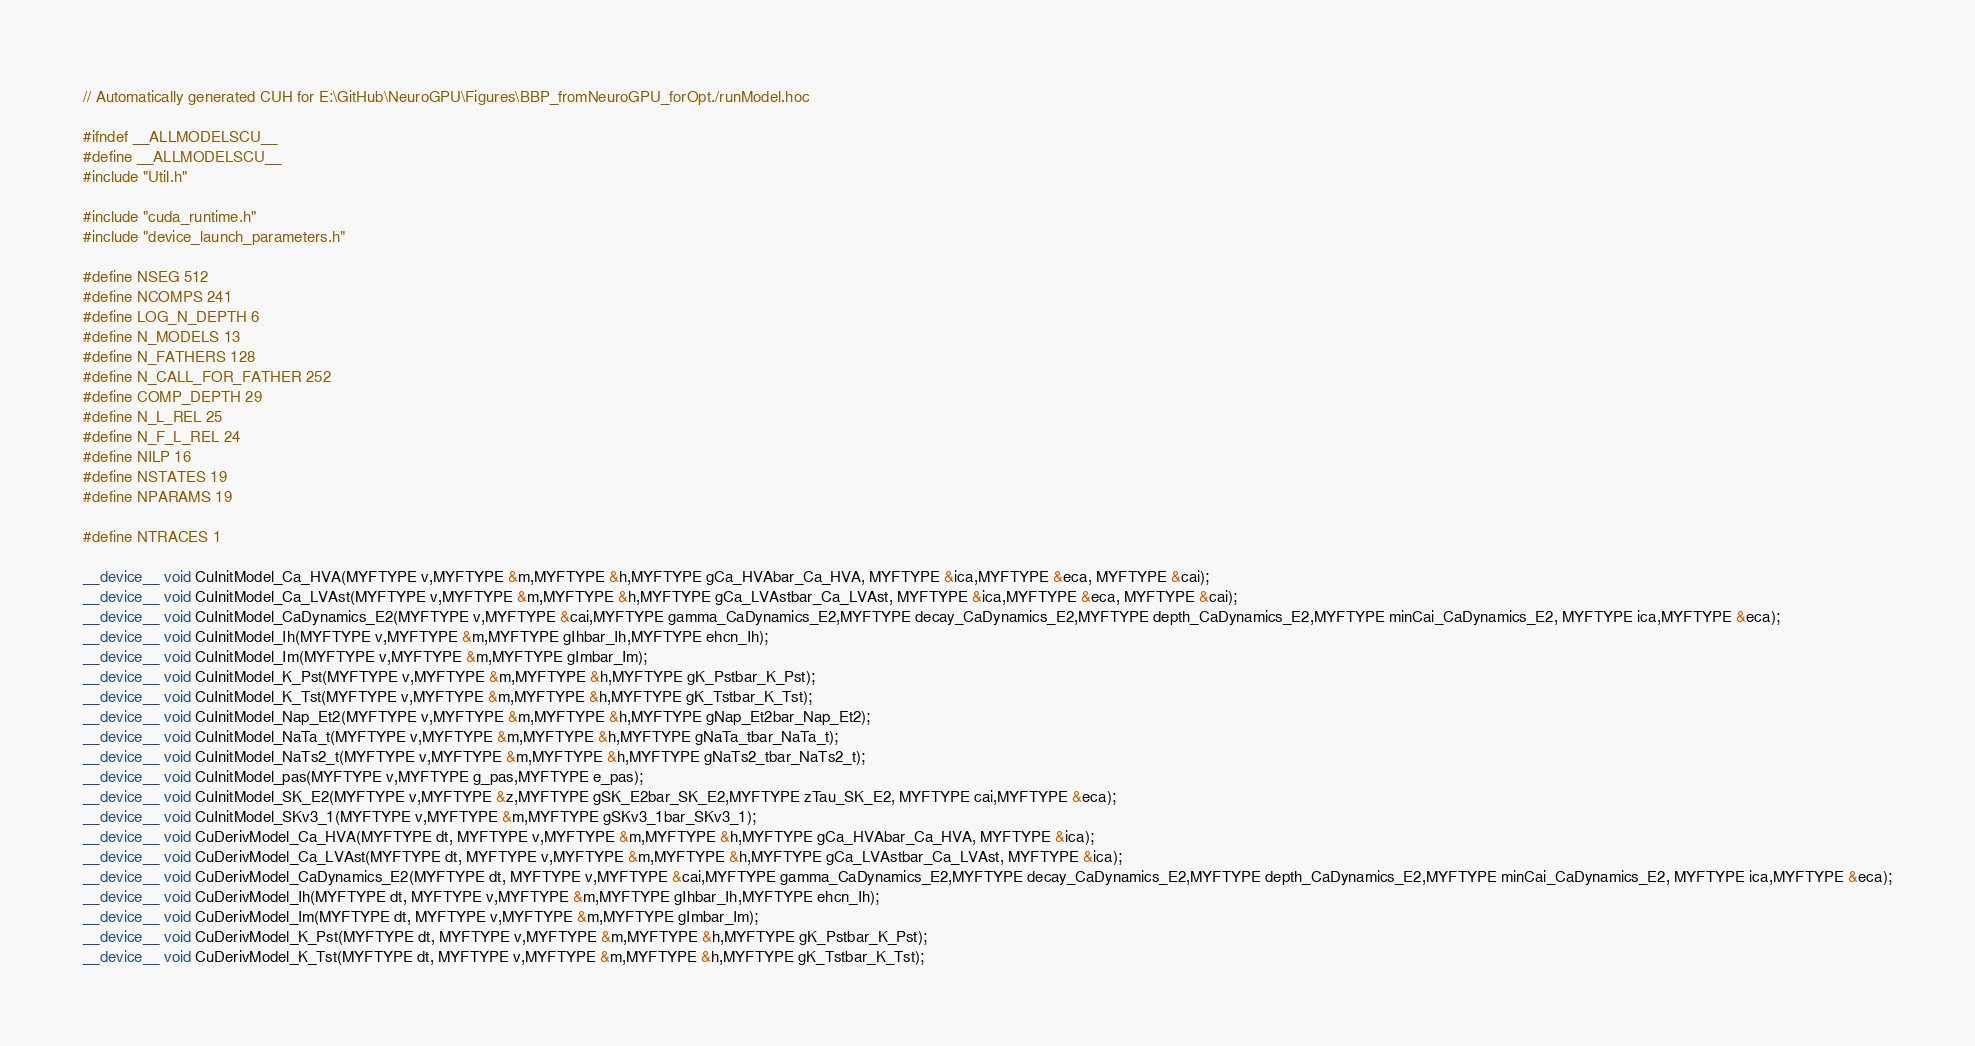<code> <loc_0><loc_0><loc_500><loc_500><_Cuda_>// Automatically generated CUH for E:\GitHub\NeuroGPU\Figures\BBP_fromNeuroGPU_forOpt./runModel.hoc

#ifndef __ALLMODELSCU__
#define __ALLMODELSCU__
#include "Util.h"

#include "cuda_runtime.h"
#include "device_launch_parameters.h"

#define NSEG 512
#define NCOMPS 241
#define LOG_N_DEPTH 6
#define N_MODELS 13
#define N_FATHERS 128
#define N_CALL_FOR_FATHER 252
#define COMP_DEPTH 29
#define N_L_REL 25
#define N_F_L_REL 24
#define NILP 16
#define NSTATES 19
#define NPARAMS 19

#define NTRACES 1

__device__ void CuInitModel_Ca_HVA(MYFTYPE v,MYFTYPE &m,MYFTYPE &h,MYFTYPE gCa_HVAbar_Ca_HVA, MYFTYPE &ica,MYFTYPE &eca, MYFTYPE &cai);
__device__ void CuInitModel_Ca_LVAst(MYFTYPE v,MYFTYPE &m,MYFTYPE &h,MYFTYPE gCa_LVAstbar_Ca_LVAst, MYFTYPE &ica,MYFTYPE &eca, MYFTYPE &cai);
__device__ void CuInitModel_CaDynamics_E2(MYFTYPE v,MYFTYPE &cai,MYFTYPE gamma_CaDynamics_E2,MYFTYPE decay_CaDynamics_E2,MYFTYPE depth_CaDynamics_E2,MYFTYPE minCai_CaDynamics_E2, MYFTYPE ica,MYFTYPE &eca);
__device__ void CuInitModel_Ih(MYFTYPE v,MYFTYPE &m,MYFTYPE gIhbar_Ih,MYFTYPE ehcn_Ih);
__device__ void CuInitModel_Im(MYFTYPE v,MYFTYPE &m,MYFTYPE gImbar_Im);
__device__ void CuInitModel_K_Pst(MYFTYPE v,MYFTYPE &m,MYFTYPE &h,MYFTYPE gK_Pstbar_K_Pst);
__device__ void CuInitModel_K_Tst(MYFTYPE v,MYFTYPE &m,MYFTYPE &h,MYFTYPE gK_Tstbar_K_Tst);
__device__ void CuInitModel_Nap_Et2(MYFTYPE v,MYFTYPE &m,MYFTYPE &h,MYFTYPE gNap_Et2bar_Nap_Et2);
__device__ void CuInitModel_NaTa_t(MYFTYPE v,MYFTYPE &m,MYFTYPE &h,MYFTYPE gNaTa_tbar_NaTa_t);
__device__ void CuInitModel_NaTs2_t(MYFTYPE v,MYFTYPE &m,MYFTYPE &h,MYFTYPE gNaTs2_tbar_NaTs2_t);
__device__ void CuInitModel_pas(MYFTYPE v,MYFTYPE g_pas,MYFTYPE e_pas);
__device__ void CuInitModel_SK_E2(MYFTYPE v,MYFTYPE &z,MYFTYPE gSK_E2bar_SK_E2,MYFTYPE zTau_SK_E2, MYFTYPE cai,MYFTYPE &eca);
__device__ void CuInitModel_SKv3_1(MYFTYPE v,MYFTYPE &m,MYFTYPE gSKv3_1bar_SKv3_1);
__device__ void CuDerivModel_Ca_HVA(MYFTYPE dt, MYFTYPE v,MYFTYPE &m,MYFTYPE &h,MYFTYPE gCa_HVAbar_Ca_HVA, MYFTYPE &ica);
__device__ void CuDerivModel_Ca_LVAst(MYFTYPE dt, MYFTYPE v,MYFTYPE &m,MYFTYPE &h,MYFTYPE gCa_LVAstbar_Ca_LVAst, MYFTYPE &ica);
__device__ void CuDerivModel_CaDynamics_E2(MYFTYPE dt, MYFTYPE v,MYFTYPE &cai,MYFTYPE gamma_CaDynamics_E2,MYFTYPE decay_CaDynamics_E2,MYFTYPE depth_CaDynamics_E2,MYFTYPE minCai_CaDynamics_E2, MYFTYPE ica,MYFTYPE &eca);
__device__ void CuDerivModel_Ih(MYFTYPE dt, MYFTYPE v,MYFTYPE &m,MYFTYPE gIhbar_Ih,MYFTYPE ehcn_Ih);
__device__ void CuDerivModel_Im(MYFTYPE dt, MYFTYPE v,MYFTYPE &m,MYFTYPE gImbar_Im);
__device__ void CuDerivModel_K_Pst(MYFTYPE dt, MYFTYPE v,MYFTYPE &m,MYFTYPE &h,MYFTYPE gK_Pstbar_K_Pst);
__device__ void CuDerivModel_K_Tst(MYFTYPE dt, MYFTYPE v,MYFTYPE &m,MYFTYPE &h,MYFTYPE gK_Tstbar_K_Tst);</code> 